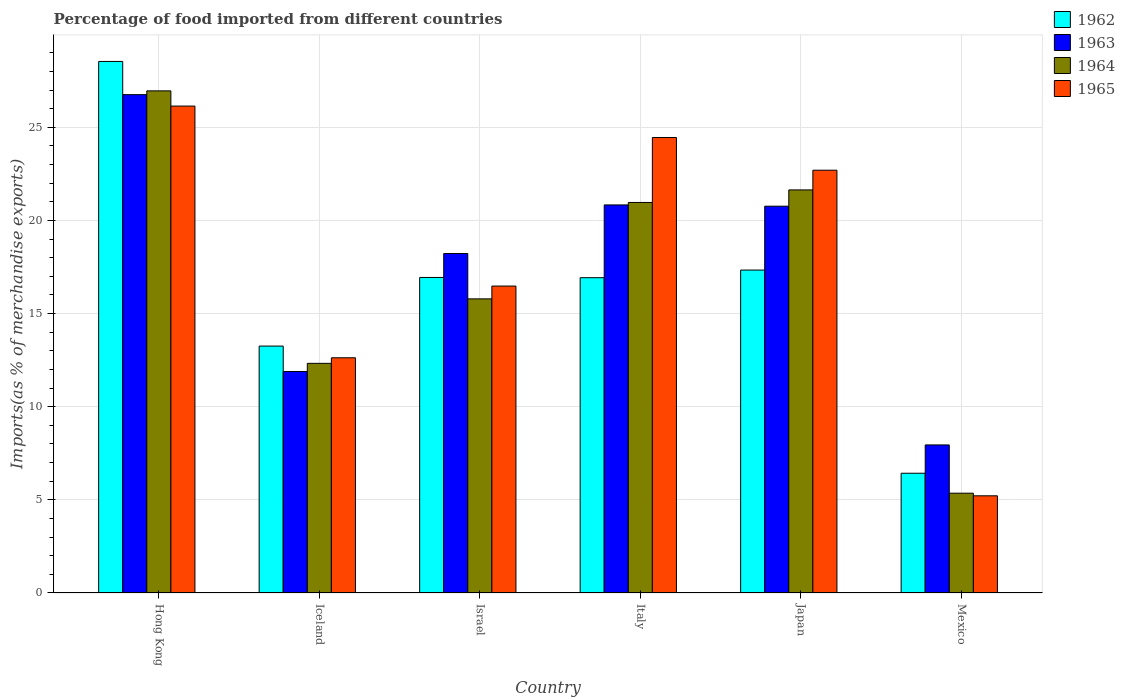Are the number of bars per tick equal to the number of legend labels?
Keep it short and to the point. Yes. Are the number of bars on each tick of the X-axis equal?
Your answer should be very brief. Yes. How many bars are there on the 1st tick from the left?
Ensure brevity in your answer.  4. How many bars are there on the 4th tick from the right?
Your answer should be compact. 4. What is the label of the 2nd group of bars from the left?
Make the answer very short. Iceland. What is the percentage of imports to different countries in 1963 in Italy?
Make the answer very short. 20.83. Across all countries, what is the maximum percentage of imports to different countries in 1963?
Make the answer very short. 26.75. Across all countries, what is the minimum percentage of imports to different countries in 1962?
Make the answer very short. 6.43. In which country was the percentage of imports to different countries in 1963 maximum?
Provide a succinct answer. Hong Kong. What is the total percentage of imports to different countries in 1963 in the graph?
Offer a terse response. 106.41. What is the difference between the percentage of imports to different countries in 1964 in Hong Kong and that in Israel?
Make the answer very short. 11.17. What is the difference between the percentage of imports to different countries in 1964 in Mexico and the percentage of imports to different countries in 1962 in Hong Kong?
Give a very brief answer. -23.18. What is the average percentage of imports to different countries in 1965 per country?
Provide a short and direct response. 17.94. What is the difference between the percentage of imports to different countries of/in 1962 and percentage of imports to different countries of/in 1965 in Mexico?
Provide a short and direct response. 1.21. In how many countries, is the percentage of imports to different countries in 1963 greater than 3 %?
Make the answer very short. 6. What is the ratio of the percentage of imports to different countries in 1962 in Hong Kong to that in Israel?
Your answer should be compact. 1.68. Is the percentage of imports to different countries in 1965 in Israel less than that in Mexico?
Keep it short and to the point. No. What is the difference between the highest and the second highest percentage of imports to different countries in 1964?
Your answer should be compact. 5.99. What is the difference between the highest and the lowest percentage of imports to different countries in 1965?
Provide a short and direct response. 20.92. What does the 4th bar from the left in Mexico represents?
Your response must be concise. 1965. What does the 1st bar from the right in Mexico represents?
Provide a succinct answer. 1965. Is it the case that in every country, the sum of the percentage of imports to different countries in 1963 and percentage of imports to different countries in 1962 is greater than the percentage of imports to different countries in 1965?
Offer a very short reply. Yes. Are all the bars in the graph horizontal?
Ensure brevity in your answer.  No. How many countries are there in the graph?
Provide a succinct answer. 6. Does the graph contain any zero values?
Provide a short and direct response. No. Where does the legend appear in the graph?
Your answer should be compact. Top right. How are the legend labels stacked?
Your response must be concise. Vertical. What is the title of the graph?
Your response must be concise. Percentage of food imported from different countries. What is the label or title of the Y-axis?
Your answer should be compact. Imports(as % of merchandise exports). What is the Imports(as % of merchandise exports) in 1962 in Hong Kong?
Your response must be concise. 28.53. What is the Imports(as % of merchandise exports) in 1963 in Hong Kong?
Give a very brief answer. 26.75. What is the Imports(as % of merchandise exports) in 1964 in Hong Kong?
Your answer should be very brief. 26.96. What is the Imports(as % of merchandise exports) of 1965 in Hong Kong?
Offer a terse response. 26.14. What is the Imports(as % of merchandise exports) in 1962 in Iceland?
Offer a terse response. 13.26. What is the Imports(as % of merchandise exports) of 1963 in Iceland?
Your answer should be compact. 11.89. What is the Imports(as % of merchandise exports) in 1964 in Iceland?
Keep it short and to the point. 12.33. What is the Imports(as % of merchandise exports) of 1965 in Iceland?
Keep it short and to the point. 12.63. What is the Imports(as % of merchandise exports) in 1962 in Israel?
Your response must be concise. 16.94. What is the Imports(as % of merchandise exports) of 1963 in Israel?
Offer a very short reply. 18.22. What is the Imports(as % of merchandise exports) in 1964 in Israel?
Make the answer very short. 15.79. What is the Imports(as % of merchandise exports) in 1965 in Israel?
Keep it short and to the point. 16.48. What is the Imports(as % of merchandise exports) of 1962 in Italy?
Ensure brevity in your answer.  16.93. What is the Imports(as % of merchandise exports) of 1963 in Italy?
Give a very brief answer. 20.83. What is the Imports(as % of merchandise exports) in 1964 in Italy?
Offer a very short reply. 20.97. What is the Imports(as % of merchandise exports) of 1965 in Italy?
Offer a terse response. 24.45. What is the Imports(as % of merchandise exports) of 1962 in Japan?
Your response must be concise. 17.34. What is the Imports(as % of merchandise exports) in 1963 in Japan?
Offer a very short reply. 20.76. What is the Imports(as % of merchandise exports) of 1964 in Japan?
Offer a terse response. 21.64. What is the Imports(as % of merchandise exports) of 1965 in Japan?
Provide a succinct answer. 22.7. What is the Imports(as % of merchandise exports) of 1962 in Mexico?
Your answer should be compact. 6.43. What is the Imports(as % of merchandise exports) in 1963 in Mexico?
Offer a very short reply. 7.95. What is the Imports(as % of merchandise exports) in 1964 in Mexico?
Ensure brevity in your answer.  5.36. What is the Imports(as % of merchandise exports) of 1965 in Mexico?
Keep it short and to the point. 5.22. Across all countries, what is the maximum Imports(as % of merchandise exports) in 1962?
Keep it short and to the point. 28.53. Across all countries, what is the maximum Imports(as % of merchandise exports) of 1963?
Your response must be concise. 26.75. Across all countries, what is the maximum Imports(as % of merchandise exports) of 1964?
Ensure brevity in your answer.  26.96. Across all countries, what is the maximum Imports(as % of merchandise exports) of 1965?
Give a very brief answer. 26.14. Across all countries, what is the minimum Imports(as % of merchandise exports) of 1962?
Your answer should be compact. 6.43. Across all countries, what is the minimum Imports(as % of merchandise exports) of 1963?
Offer a very short reply. 7.95. Across all countries, what is the minimum Imports(as % of merchandise exports) in 1964?
Your response must be concise. 5.36. Across all countries, what is the minimum Imports(as % of merchandise exports) of 1965?
Ensure brevity in your answer.  5.22. What is the total Imports(as % of merchandise exports) in 1962 in the graph?
Provide a succinct answer. 99.42. What is the total Imports(as % of merchandise exports) of 1963 in the graph?
Offer a terse response. 106.41. What is the total Imports(as % of merchandise exports) in 1964 in the graph?
Provide a short and direct response. 103.03. What is the total Imports(as % of merchandise exports) of 1965 in the graph?
Your answer should be compact. 107.61. What is the difference between the Imports(as % of merchandise exports) of 1962 in Hong Kong and that in Iceland?
Your answer should be compact. 15.28. What is the difference between the Imports(as % of merchandise exports) of 1963 in Hong Kong and that in Iceland?
Provide a succinct answer. 14.86. What is the difference between the Imports(as % of merchandise exports) of 1964 in Hong Kong and that in Iceland?
Provide a succinct answer. 14.63. What is the difference between the Imports(as % of merchandise exports) of 1965 in Hong Kong and that in Iceland?
Your answer should be compact. 13.51. What is the difference between the Imports(as % of merchandise exports) of 1962 in Hong Kong and that in Israel?
Offer a terse response. 11.6. What is the difference between the Imports(as % of merchandise exports) in 1963 in Hong Kong and that in Israel?
Ensure brevity in your answer.  8.53. What is the difference between the Imports(as % of merchandise exports) in 1964 in Hong Kong and that in Israel?
Your answer should be very brief. 11.17. What is the difference between the Imports(as % of merchandise exports) in 1965 in Hong Kong and that in Israel?
Give a very brief answer. 9.66. What is the difference between the Imports(as % of merchandise exports) in 1962 in Hong Kong and that in Italy?
Provide a short and direct response. 11.61. What is the difference between the Imports(as % of merchandise exports) in 1963 in Hong Kong and that in Italy?
Give a very brief answer. 5.92. What is the difference between the Imports(as % of merchandise exports) of 1964 in Hong Kong and that in Italy?
Provide a short and direct response. 5.99. What is the difference between the Imports(as % of merchandise exports) in 1965 in Hong Kong and that in Italy?
Provide a succinct answer. 1.69. What is the difference between the Imports(as % of merchandise exports) in 1962 in Hong Kong and that in Japan?
Provide a succinct answer. 11.2. What is the difference between the Imports(as % of merchandise exports) in 1963 in Hong Kong and that in Japan?
Offer a very short reply. 5.99. What is the difference between the Imports(as % of merchandise exports) of 1964 in Hong Kong and that in Japan?
Offer a terse response. 5.32. What is the difference between the Imports(as % of merchandise exports) of 1965 in Hong Kong and that in Japan?
Your answer should be compact. 3.44. What is the difference between the Imports(as % of merchandise exports) of 1962 in Hong Kong and that in Mexico?
Offer a terse response. 22.11. What is the difference between the Imports(as % of merchandise exports) in 1963 in Hong Kong and that in Mexico?
Your answer should be compact. 18.8. What is the difference between the Imports(as % of merchandise exports) in 1964 in Hong Kong and that in Mexico?
Make the answer very short. 21.6. What is the difference between the Imports(as % of merchandise exports) of 1965 in Hong Kong and that in Mexico?
Your answer should be compact. 20.92. What is the difference between the Imports(as % of merchandise exports) in 1962 in Iceland and that in Israel?
Offer a very short reply. -3.68. What is the difference between the Imports(as % of merchandise exports) of 1963 in Iceland and that in Israel?
Offer a terse response. -6.33. What is the difference between the Imports(as % of merchandise exports) of 1964 in Iceland and that in Israel?
Provide a succinct answer. -3.46. What is the difference between the Imports(as % of merchandise exports) in 1965 in Iceland and that in Israel?
Your response must be concise. -3.85. What is the difference between the Imports(as % of merchandise exports) in 1962 in Iceland and that in Italy?
Your answer should be compact. -3.67. What is the difference between the Imports(as % of merchandise exports) of 1963 in Iceland and that in Italy?
Your response must be concise. -8.94. What is the difference between the Imports(as % of merchandise exports) of 1964 in Iceland and that in Italy?
Offer a terse response. -8.64. What is the difference between the Imports(as % of merchandise exports) in 1965 in Iceland and that in Italy?
Your answer should be very brief. -11.82. What is the difference between the Imports(as % of merchandise exports) of 1962 in Iceland and that in Japan?
Offer a very short reply. -4.08. What is the difference between the Imports(as % of merchandise exports) in 1963 in Iceland and that in Japan?
Provide a succinct answer. -8.87. What is the difference between the Imports(as % of merchandise exports) of 1964 in Iceland and that in Japan?
Offer a very short reply. -9.31. What is the difference between the Imports(as % of merchandise exports) of 1965 in Iceland and that in Japan?
Make the answer very short. -10.07. What is the difference between the Imports(as % of merchandise exports) of 1962 in Iceland and that in Mexico?
Give a very brief answer. 6.83. What is the difference between the Imports(as % of merchandise exports) in 1963 in Iceland and that in Mexico?
Give a very brief answer. 3.94. What is the difference between the Imports(as % of merchandise exports) in 1964 in Iceland and that in Mexico?
Provide a short and direct response. 6.97. What is the difference between the Imports(as % of merchandise exports) of 1965 in Iceland and that in Mexico?
Provide a short and direct response. 7.41. What is the difference between the Imports(as % of merchandise exports) of 1962 in Israel and that in Italy?
Your answer should be compact. 0.01. What is the difference between the Imports(as % of merchandise exports) in 1963 in Israel and that in Italy?
Give a very brief answer. -2.61. What is the difference between the Imports(as % of merchandise exports) in 1964 in Israel and that in Italy?
Ensure brevity in your answer.  -5.18. What is the difference between the Imports(as % of merchandise exports) of 1965 in Israel and that in Italy?
Your response must be concise. -7.97. What is the difference between the Imports(as % of merchandise exports) in 1962 in Israel and that in Japan?
Offer a terse response. -0.4. What is the difference between the Imports(as % of merchandise exports) in 1963 in Israel and that in Japan?
Your answer should be very brief. -2.54. What is the difference between the Imports(as % of merchandise exports) in 1964 in Israel and that in Japan?
Offer a terse response. -5.85. What is the difference between the Imports(as % of merchandise exports) in 1965 in Israel and that in Japan?
Keep it short and to the point. -6.22. What is the difference between the Imports(as % of merchandise exports) in 1962 in Israel and that in Mexico?
Ensure brevity in your answer.  10.51. What is the difference between the Imports(as % of merchandise exports) of 1963 in Israel and that in Mexico?
Offer a very short reply. 10.28. What is the difference between the Imports(as % of merchandise exports) in 1964 in Israel and that in Mexico?
Provide a short and direct response. 10.43. What is the difference between the Imports(as % of merchandise exports) in 1965 in Israel and that in Mexico?
Offer a terse response. 11.26. What is the difference between the Imports(as % of merchandise exports) in 1962 in Italy and that in Japan?
Make the answer very short. -0.41. What is the difference between the Imports(as % of merchandise exports) of 1963 in Italy and that in Japan?
Ensure brevity in your answer.  0.07. What is the difference between the Imports(as % of merchandise exports) in 1964 in Italy and that in Japan?
Keep it short and to the point. -0.67. What is the difference between the Imports(as % of merchandise exports) in 1965 in Italy and that in Japan?
Keep it short and to the point. 1.76. What is the difference between the Imports(as % of merchandise exports) of 1962 in Italy and that in Mexico?
Make the answer very short. 10.5. What is the difference between the Imports(as % of merchandise exports) in 1963 in Italy and that in Mexico?
Provide a succinct answer. 12.88. What is the difference between the Imports(as % of merchandise exports) of 1964 in Italy and that in Mexico?
Your response must be concise. 15.61. What is the difference between the Imports(as % of merchandise exports) of 1965 in Italy and that in Mexico?
Offer a terse response. 19.24. What is the difference between the Imports(as % of merchandise exports) in 1962 in Japan and that in Mexico?
Ensure brevity in your answer.  10.91. What is the difference between the Imports(as % of merchandise exports) of 1963 in Japan and that in Mexico?
Offer a very short reply. 12.82. What is the difference between the Imports(as % of merchandise exports) of 1964 in Japan and that in Mexico?
Your answer should be compact. 16.28. What is the difference between the Imports(as % of merchandise exports) of 1965 in Japan and that in Mexico?
Your answer should be very brief. 17.48. What is the difference between the Imports(as % of merchandise exports) of 1962 in Hong Kong and the Imports(as % of merchandise exports) of 1963 in Iceland?
Give a very brief answer. 16.65. What is the difference between the Imports(as % of merchandise exports) of 1962 in Hong Kong and the Imports(as % of merchandise exports) of 1964 in Iceland?
Ensure brevity in your answer.  16.21. What is the difference between the Imports(as % of merchandise exports) of 1962 in Hong Kong and the Imports(as % of merchandise exports) of 1965 in Iceland?
Your answer should be very brief. 15.91. What is the difference between the Imports(as % of merchandise exports) of 1963 in Hong Kong and the Imports(as % of merchandise exports) of 1964 in Iceland?
Offer a very short reply. 14.43. What is the difference between the Imports(as % of merchandise exports) of 1963 in Hong Kong and the Imports(as % of merchandise exports) of 1965 in Iceland?
Provide a succinct answer. 14.13. What is the difference between the Imports(as % of merchandise exports) in 1964 in Hong Kong and the Imports(as % of merchandise exports) in 1965 in Iceland?
Keep it short and to the point. 14.33. What is the difference between the Imports(as % of merchandise exports) in 1962 in Hong Kong and the Imports(as % of merchandise exports) in 1963 in Israel?
Keep it short and to the point. 10.31. What is the difference between the Imports(as % of merchandise exports) in 1962 in Hong Kong and the Imports(as % of merchandise exports) in 1964 in Israel?
Your answer should be very brief. 12.75. What is the difference between the Imports(as % of merchandise exports) in 1962 in Hong Kong and the Imports(as % of merchandise exports) in 1965 in Israel?
Provide a succinct answer. 12.06. What is the difference between the Imports(as % of merchandise exports) of 1963 in Hong Kong and the Imports(as % of merchandise exports) of 1964 in Israel?
Your response must be concise. 10.96. What is the difference between the Imports(as % of merchandise exports) in 1963 in Hong Kong and the Imports(as % of merchandise exports) in 1965 in Israel?
Your answer should be compact. 10.28. What is the difference between the Imports(as % of merchandise exports) in 1964 in Hong Kong and the Imports(as % of merchandise exports) in 1965 in Israel?
Offer a terse response. 10.48. What is the difference between the Imports(as % of merchandise exports) in 1962 in Hong Kong and the Imports(as % of merchandise exports) in 1963 in Italy?
Provide a succinct answer. 7.7. What is the difference between the Imports(as % of merchandise exports) in 1962 in Hong Kong and the Imports(as % of merchandise exports) in 1964 in Italy?
Your answer should be compact. 7.57. What is the difference between the Imports(as % of merchandise exports) in 1962 in Hong Kong and the Imports(as % of merchandise exports) in 1965 in Italy?
Provide a succinct answer. 4.08. What is the difference between the Imports(as % of merchandise exports) of 1963 in Hong Kong and the Imports(as % of merchandise exports) of 1964 in Italy?
Ensure brevity in your answer.  5.79. What is the difference between the Imports(as % of merchandise exports) in 1963 in Hong Kong and the Imports(as % of merchandise exports) in 1965 in Italy?
Ensure brevity in your answer.  2.3. What is the difference between the Imports(as % of merchandise exports) in 1964 in Hong Kong and the Imports(as % of merchandise exports) in 1965 in Italy?
Give a very brief answer. 2.5. What is the difference between the Imports(as % of merchandise exports) of 1962 in Hong Kong and the Imports(as % of merchandise exports) of 1963 in Japan?
Your answer should be compact. 7.77. What is the difference between the Imports(as % of merchandise exports) of 1962 in Hong Kong and the Imports(as % of merchandise exports) of 1964 in Japan?
Your response must be concise. 6.9. What is the difference between the Imports(as % of merchandise exports) in 1962 in Hong Kong and the Imports(as % of merchandise exports) in 1965 in Japan?
Keep it short and to the point. 5.84. What is the difference between the Imports(as % of merchandise exports) of 1963 in Hong Kong and the Imports(as % of merchandise exports) of 1964 in Japan?
Offer a terse response. 5.11. What is the difference between the Imports(as % of merchandise exports) in 1963 in Hong Kong and the Imports(as % of merchandise exports) in 1965 in Japan?
Offer a very short reply. 4.06. What is the difference between the Imports(as % of merchandise exports) of 1964 in Hong Kong and the Imports(as % of merchandise exports) of 1965 in Japan?
Offer a terse response. 4.26. What is the difference between the Imports(as % of merchandise exports) of 1962 in Hong Kong and the Imports(as % of merchandise exports) of 1963 in Mexico?
Your answer should be very brief. 20.59. What is the difference between the Imports(as % of merchandise exports) of 1962 in Hong Kong and the Imports(as % of merchandise exports) of 1964 in Mexico?
Provide a short and direct response. 23.18. What is the difference between the Imports(as % of merchandise exports) in 1962 in Hong Kong and the Imports(as % of merchandise exports) in 1965 in Mexico?
Keep it short and to the point. 23.32. What is the difference between the Imports(as % of merchandise exports) of 1963 in Hong Kong and the Imports(as % of merchandise exports) of 1964 in Mexico?
Make the answer very short. 21.4. What is the difference between the Imports(as % of merchandise exports) in 1963 in Hong Kong and the Imports(as % of merchandise exports) in 1965 in Mexico?
Your response must be concise. 21.54. What is the difference between the Imports(as % of merchandise exports) of 1964 in Hong Kong and the Imports(as % of merchandise exports) of 1965 in Mexico?
Offer a terse response. 21.74. What is the difference between the Imports(as % of merchandise exports) of 1962 in Iceland and the Imports(as % of merchandise exports) of 1963 in Israel?
Offer a terse response. -4.97. What is the difference between the Imports(as % of merchandise exports) in 1962 in Iceland and the Imports(as % of merchandise exports) in 1964 in Israel?
Provide a succinct answer. -2.53. What is the difference between the Imports(as % of merchandise exports) of 1962 in Iceland and the Imports(as % of merchandise exports) of 1965 in Israel?
Provide a short and direct response. -3.22. What is the difference between the Imports(as % of merchandise exports) of 1963 in Iceland and the Imports(as % of merchandise exports) of 1964 in Israel?
Your answer should be compact. -3.9. What is the difference between the Imports(as % of merchandise exports) of 1963 in Iceland and the Imports(as % of merchandise exports) of 1965 in Israel?
Make the answer very short. -4.59. What is the difference between the Imports(as % of merchandise exports) of 1964 in Iceland and the Imports(as % of merchandise exports) of 1965 in Israel?
Give a very brief answer. -4.15. What is the difference between the Imports(as % of merchandise exports) of 1962 in Iceland and the Imports(as % of merchandise exports) of 1963 in Italy?
Give a very brief answer. -7.58. What is the difference between the Imports(as % of merchandise exports) in 1962 in Iceland and the Imports(as % of merchandise exports) in 1964 in Italy?
Give a very brief answer. -7.71. What is the difference between the Imports(as % of merchandise exports) in 1962 in Iceland and the Imports(as % of merchandise exports) in 1965 in Italy?
Give a very brief answer. -11.2. What is the difference between the Imports(as % of merchandise exports) of 1963 in Iceland and the Imports(as % of merchandise exports) of 1964 in Italy?
Your answer should be compact. -9.08. What is the difference between the Imports(as % of merchandise exports) of 1963 in Iceland and the Imports(as % of merchandise exports) of 1965 in Italy?
Provide a short and direct response. -12.56. What is the difference between the Imports(as % of merchandise exports) of 1964 in Iceland and the Imports(as % of merchandise exports) of 1965 in Italy?
Ensure brevity in your answer.  -12.13. What is the difference between the Imports(as % of merchandise exports) of 1962 in Iceland and the Imports(as % of merchandise exports) of 1963 in Japan?
Provide a succinct answer. -7.51. What is the difference between the Imports(as % of merchandise exports) in 1962 in Iceland and the Imports(as % of merchandise exports) in 1964 in Japan?
Make the answer very short. -8.38. What is the difference between the Imports(as % of merchandise exports) of 1962 in Iceland and the Imports(as % of merchandise exports) of 1965 in Japan?
Your answer should be very brief. -9.44. What is the difference between the Imports(as % of merchandise exports) of 1963 in Iceland and the Imports(as % of merchandise exports) of 1964 in Japan?
Keep it short and to the point. -9.75. What is the difference between the Imports(as % of merchandise exports) in 1963 in Iceland and the Imports(as % of merchandise exports) in 1965 in Japan?
Make the answer very short. -10.81. What is the difference between the Imports(as % of merchandise exports) of 1964 in Iceland and the Imports(as % of merchandise exports) of 1965 in Japan?
Offer a terse response. -10.37. What is the difference between the Imports(as % of merchandise exports) of 1962 in Iceland and the Imports(as % of merchandise exports) of 1963 in Mexico?
Provide a short and direct response. 5.31. What is the difference between the Imports(as % of merchandise exports) of 1962 in Iceland and the Imports(as % of merchandise exports) of 1964 in Mexico?
Make the answer very short. 7.9. What is the difference between the Imports(as % of merchandise exports) in 1962 in Iceland and the Imports(as % of merchandise exports) in 1965 in Mexico?
Make the answer very short. 8.04. What is the difference between the Imports(as % of merchandise exports) in 1963 in Iceland and the Imports(as % of merchandise exports) in 1964 in Mexico?
Provide a short and direct response. 6.53. What is the difference between the Imports(as % of merchandise exports) in 1963 in Iceland and the Imports(as % of merchandise exports) in 1965 in Mexico?
Make the answer very short. 6.67. What is the difference between the Imports(as % of merchandise exports) of 1964 in Iceland and the Imports(as % of merchandise exports) of 1965 in Mexico?
Offer a terse response. 7.11. What is the difference between the Imports(as % of merchandise exports) of 1962 in Israel and the Imports(as % of merchandise exports) of 1963 in Italy?
Offer a very short reply. -3.89. What is the difference between the Imports(as % of merchandise exports) in 1962 in Israel and the Imports(as % of merchandise exports) in 1964 in Italy?
Offer a terse response. -4.03. What is the difference between the Imports(as % of merchandise exports) in 1962 in Israel and the Imports(as % of merchandise exports) in 1965 in Italy?
Make the answer very short. -7.51. What is the difference between the Imports(as % of merchandise exports) in 1963 in Israel and the Imports(as % of merchandise exports) in 1964 in Italy?
Ensure brevity in your answer.  -2.74. What is the difference between the Imports(as % of merchandise exports) of 1963 in Israel and the Imports(as % of merchandise exports) of 1965 in Italy?
Give a very brief answer. -6.23. What is the difference between the Imports(as % of merchandise exports) in 1964 in Israel and the Imports(as % of merchandise exports) in 1965 in Italy?
Your answer should be compact. -8.66. What is the difference between the Imports(as % of merchandise exports) in 1962 in Israel and the Imports(as % of merchandise exports) in 1963 in Japan?
Give a very brief answer. -3.83. What is the difference between the Imports(as % of merchandise exports) of 1962 in Israel and the Imports(as % of merchandise exports) of 1964 in Japan?
Provide a short and direct response. -4.7. What is the difference between the Imports(as % of merchandise exports) in 1962 in Israel and the Imports(as % of merchandise exports) in 1965 in Japan?
Make the answer very short. -5.76. What is the difference between the Imports(as % of merchandise exports) of 1963 in Israel and the Imports(as % of merchandise exports) of 1964 in Japan?
Make the answer very short. -3.41. What is the difference between the Imports(as % of merchandise exports) in 1963 in Israel and the Imports(as % of merchandise exports) in 1965 in Japan?
Offer a very short reply. -4.47. What is the difference between the Imports(as % of merchandise exports) of 1964 in Israel and the Imports(as % of merchandise exports) of 1965 in Japan?
Provide a short and direct response. -6.91. What is the difference between the Imports(as % of merchandise exports) of 1962 in Israel and the Imports(as % of merchandise exports) of 1963 in Mexico?
Provide a short and direct response. 8.99. What is the difference between the Imports(as % of merchandise exports) in 1962 in Israel and the Imports(as % of merchandise exports) in 1964 in Mexico?
Your response must be concise. 11.58. What is the difference between the Imports(as % of merchandise exports) of 1962 in Israel and the Imports(as % of merchandise exports) of 1965 in Mexico?
Make the answer very short. 11.72. What is the difference between the Imports(as % of merchandise exports) of 1963 in Israel and the Imports(as % of merchandise exports) of 1964 in Mexico?
Your response must be concise. 12.87. What is the difference between the Imports(as % of merchandise exports) of 1963 in Israel and the Imports(as % of merchandise exports) of 1965 in Mexico?
Offer a very short reply. 13.01. What is the difference between the Imports(as % of merchandise exports) in 1964 in Israel and the Imports(as % of merchandise exports) in 1965 in Mexico?
Your answer should be very brief. 10.57. What is the difference between the Imports(as % of merchandise exports) in 1962 in Italy and the Imports(as % of merchandise exports) in 1963 in Japan?
Your response must be concise. -3.84. What is the difference between the Imports(as % of merchandise exports) in 1962 in Italy and the Imports(as % of merchandise exports) in 1964 in Japan?
Ensure brevity in your answer.  -4.71. What is the difference between the Imports(as % of merchandise exports) of 1962 in Italy and the Imports(as % of merchandise exports) of 1965 in Japan?
Provide a short and direct response. -5.77. What is the difference between the Imports(as % of merchandise exports) of 1963 in Italy and the Imports(as % of merchandise exports) of 1964 in Japan?
Keep it short and to the point. -0.81. What is the difference between the Imports(as % of merchandise exports) in 1963 in Italy and the Imports(as % of merchandise exports) in 1965 in Japan?
Offer a terse response. -1.86. What is the difference between the Imports(as % of merchandise exports) of 1964 in Italy and the Imports(as % of merchandise exports) of 1965 in Japan?
Provide a short and direct response. -1.73. What is the difference between the Imports(as % of merchandise exports) of 1962 in Italy and the Imports(as % of merchandise exports) of 1963 in Mexico?
Ensure brevity in your answer.  8.98. What is the difference between the Imports(as % of merchandise exports) in 1962 in Italy and the Imports(as % of merchandise exports) in 1964 in Mexico?
Your response must be concise. 11.57. What is the difference between the Imports(as % of merchandise exports) in 1962 in Italy and the Imports(as % of merchandise exports) in 1965 in Mexico?
Offer a terse response. 11.71. What is the difference between the Imports(as % of merchandise exports) of 1963 in Italy and the Imports(as % of merchandise exports) of 1964 in Mexico?
Make the answer very short. 15.48. What is the difference between the Imports(as % of merchandise exports) in 1963 in Italy and the Imports(as % of merchandise exports) in 1965 in Mexico?
Keep it short and to the point. 15.62. What is the difference between the Imports(as % of merchandise exports) of 1964 in Italy and the Imports(as % of merchandise exports) of 1965 in Mexico?
Offer a very short reply. 15.75. What is the difference between the Imports(as % of merchandise exports) in 1962 in Japan and the Imports(as % of merchandise exports) in 1963 in Mexico?
Offer a terse response. 9.39. What is the difference between the Imports(as % of merchandise exports) in 1962 in Japan and the Imports(as % of merchandise exports) in 1964 in Mexico?
Offer a very short reply. 11.98. What is the difference between the Imports(as % of merchandise exports) in 1962 in Japan and the Imports(as % of merchandise exports) in 1965 in Mexico?
Offer a terse response. 12.12. What is the difference between the Imports(as % of merchandise exports) in 1963 in Japan and the Imports(as % of merchandise exports) in 1964 in Mexico?
Provide a short and direct response. 15.41. What is the difference between the Imports(as % of merchandise exports) of 1963 in Japan and the Imports(as % of merchandise exports) of 1965 in Mexico?
Make the answer very short. 15.55. What is the difference between the Imports(as % of merchandise exports) of 1964 in Japan and the Imports(as % of merchandise exports) of 1965 in Mexico?
Your answer should be very brief. 16.42. What is the average Imports(as % of merchandise exports) in 1962 per country?
Ensure brevity in your answer.  16.57. What is the average Imports(as % of merchandise exports) of 1963 per country?
Provide a succinct answer. 17.74. What is the average Imports(as % of merchandise exports) of 1964 per country?
Give a very brief answer. 17.17. What is the average Imports(as % of merchandise exports) in 1965 per country?
Make the answer very short. 17.94. What is the difference between the Imports(as % of merchandise exports) of 1962 and Imports(as % of merchandise exports) of 1963 in Hong Kong?
Offer a terse response. 1.78. What is the difference between the Imports(as % of merchandise exports) of 1962 and Imports(as % of merchandise exports) of 1964 in Hong Kong?
Keep it short and to the point. 1.58. What is the difference between the Imports(as % of merchandise exports) in 1962 and Imports(as % of merchandise exports) in 1965 in Hong Kong?
Provide a short and direct response. 2.4. What is the difference between the Imports(as % of merchandise exports) of 1963 and Imports(as % of merchandise exports) of 1964 in Hong Kong?
Offer a terse response. -0.2. What is the difference between the Imports(as % of merchandise exports) of 1963 and Imports(as % of merchandise exports) of 1965 in Hong Kong?
Give a very brief answer. 0.61. What is the difference between the Imports(as % of merchandise exports) of 1964 and Imports(as % of merchandise exports) of 1965 in Hong Kong?
Your answer should be compact. 0.82. What is the difference between the Imports(as % of merchandise exports) in 1962 and Imports(as % of merchandise exports) in 1963 in Iceland?
Ensure brevity in your answer.  1.37. What is the difference between the Imports(as % of merchandise exports) of 1962 and Imports(as % of merchandise exports) of 1964 in Iceland?
Provide a succinct answer. 0.93. What is the difference between the Imports(as % of merchandise exports) in 1962 and Imports(as % of merchandise exports) in 1965 in Iceland?
Keep it short and to the point. 0.63. What is the difference between the Imports(as % of merchandise exports) in 1963 and Imports(as % of merchandise exports) in 1964 in Iceland?
Provide a succinct answer. -0.44. What is the difference between the Imports(as % of merchandise exports) in 1963 and Imports(as % of merchandise exports) in 1965 in Iceland?
Make the answer very short. -0.74. What is the difference between the Imports(as % of merchandise exports) of 1964 and Imports(as % of merchandise exports) of 1965 in Iceland?
Give a very brief answer. -0.3. What is the difference between the Imports(as % of merchandise exports) in 1962 and Imports(as % of merchandise exports) in 1963 in Israel?
Provide a succinct answer. -1.29. What is the difference between the Imports(as % of merchandise exports) in 1962 and Imports(as % of merchandise exports) in 1964 in Israel?
Offer a terse response. 1.15. What is the difference between the Imports(as % of merchandise exports) in 1962 and Imports(as % of merchandise exports) in 1965 in Israel?
Make the answer very short. 0.46. What is the difference between the Imports(as % of merchandise exports) of 1963 and Imports(as % of merchandise exports) of 1964 in Israel?
Offer a very short reply. 2.43. What is the difference between the Imports(as % of merchandise exports) of 1963 and Imports(as % of merchandise exports) of 1965 in Israel?
Offer a terse response. 1.75. What is the difference between the Imports(as % of merchandise exports) in 1964 and Imports(as % of merchandise exports) in 1965 in Israel?
Your answer should be very brief. -0.69. What is the difference between the Imports(as % of merchandise exports) of 1962 and Imports(as % of merchandise exports) of 1963 in Italy?
Your answer should be compact. -3.91. What is the difference between the Imports(as % of merchandise exports) in 1962 and Imports(as % of merchandise exports) in 1964 in Italy?
Provide a short and direct response. -4.04. What is the difference between the Imports(as % of merchandise exports) in 1962 and Imports(as % of merchandise exports) in 1965 in Italy?
Ensure brevity in your answer.  -7.53. What is the difference between the Imports(as % of merchandise exports) of 1963 and Imports(as % of merchandise exports) of 1964 in Italy?
Your answer should be compact. -0.13. What is the difference between the Imports(as % of merchandise exports) of 1963 and Imports(as % of merchandise exports) of 1965 in Italy?
Make the answer very short. -3.62. What is the difference between the Imports(as % of merchandise exports) in 1964 and Imports(as % of merchandise exports) in 1965 in Italy?
Your answer should be very brief. -3.49. What is the difference between the Imports(as % of merchandise exports) of 1962 and Imports(as % of merchandise exports) of 1963 in Japan?
Give a very brief answer. -3.43. What is the difference between the Imports(as % of merchandise exports) of 1962 and Imports(as % of merchandise exports) of 1964 in Japan?
Provide a succinct answer. -4.3. What is the difference between the Imports(as % of merchandise exports) of 1962 and Imports(as % of merchandise exports) of 1965 in Japan?
Make the answer very short. -5.36. What is the difference between the Imports(as % of merchandise exports) in 1963 and Imports(as % of merchandise exports) in 1964 in Japan?
Your response must be concise. -0.87. What is the difference between the Imports(as % of merchandise exports) of 1963 and Imports(as % of merchandise exports) of 1965 in Japan?
Your response must be concise. -1.93. What is the difference between the Imports(as % of merchandise exports) of 1964 and Imports(as % of merchandise exports) of 1965 in Japan?
Your response must be concise. -1.06. What is the difference between the Imports(as % of merchandise exports) of 1962 and Imports(as % of merchandise exports) of 1963 in Mexico?
Provide a short and direct response. -1.52. What is the difference between the Imports(as % of merchandise exports) in 1962 and Imports(as % of merchandise exports) in 1964 in Mexico?
Ensure brevity in your answer.  1.07. What is the difference between the Imports(as % of merchandise exports) of 1962 and Imports(as % of merchandise exports) of 1965 in Mexico?
Provide a short and direct response. 1.21. What is the difference between the Imports(as % of merchandise exports) of 1963 and Imports(as % of merchandise exports) of 1964 in Mexico?
Your response must be concise. 2.59. What is the difference between the Imports(as % of merchandise exports) in 1963 and Imports(as % of merchandise exports) in 1965 in Mexico?
Keep it short and to the point. 2.73. What is the difference between the Imports(as % of merchandise exports) in 1964 and Imports(as % of merchandise exports) in 1965 in Mexico?
Your answer should be compact. 0.14. What is the ratio of the Imports(as % of merchandise exports) of 1962 in Hong Kong to that in Iceland?
Your answer should be compact. 2.15. What is the ratio of the Imports(as % of merchandise exports) of 1963 in Hong Kong to that in Iceland?
Your answer should be compact. 2.25. What is the ratio of the Imports(as % of merchandise exports) of 1964 in Hong Kong to that in Iceland?
Provide a succinct answer. 2.19. What is the ratio of the Imports(as % of merchandise exports) in 1965 in Hong Kong to that in Iceland?
Your answer should be compact. 2.07. What is the ratio of the Imports(as % of merchandise exports) of 1962 in Hong Kong to that in Israel?
Provide a succinct answer. 1.68. What is the ratio of the Imports(as % of merchandise exports) in 1963 in Hong Kong to that in Israel?
Offer a very short reply. 1.47. What is the ratio of the Imports(as % of merchandise exports) in 1964 in Hong Kong to that in Israel?
Keep it short and to the point. 1.71. What is the ratio of the Imports(as % of merchandise exports) in 1965 in Hong Kong to that in Israel?
Offer a terse response. 1.59. What is the ratio of the Imports(as % of merchandise exports) of 1962 in Hong Kong to that in Italy?
Your answer should be very brief. 1.69. What is the ratio of the Imports(as % of merchandise exports) of 1963 in Hong Kong to that in Italy?
Offer a very short reply. 1.28. What is the ratio of the Imports(as % of merchandise exports) in 1965 in Hong Kong to that in Italy?
Your response must be concise. 1.07. What is the ratio of the Imports(as % of merchandise exports) in 1962 in Hong Kong to that in Japan?
Your response must be concise. 1.65. What is the ratio of the Imports(as % of merchandise exports) in 1963 in Hong Kong to that in Japan?
Your answer should be very brief. 1.29. What is the ratio of the Imports(as % of merchandise exports) in 1964 in Hong Kong to that in Japan?
Offer a very short reply. 1.25. What is the ratio of the Imports(as % of merchandise exports) in 1965 in Hong Kong to that in Japan?
Keep it short and to the point. 1.15. What is the ratio of the Imports(as % of merchandise exports) of 1962 in Hong Kong to that in Mexico?
Provide a short and direct response. 4.44. What is the ratio of the Imports(as % of merchandise exports) of 1963 in Hong Kong to that in Mexico?
Keep it short and to the point. 3.37. What is the ratio of the Imports(as % of merchandise exports) in 1964 in Hong Kong to that in Mexico?
Offer a very short reply. 5.03. What is the ratio of the Imports(as % of merchandise exports) of 1965 in Hong Kong to that in Mexico?
Keep it short and to the point. 5.01. What is the ratio of the Imports(as % of merchandise exports) in 1962 in Iceland to that in Israel?
Offer a very short reply. 0.78. What is the ratio of the Imports(as % of merchandise exports) in 1963 in Iceland to that in Israel?
Your answer should be very brief. 0.65. What is the ratio of the Imports(as % of merchandise exports) of 1964 in Iceland to that in Israel?
Your answer should be compact. 0.78. What is the ratio of the Imports(as % of merchandise exports) of 1965 in Iceland to that in Israel?
Offer a very short reply. 0.77. What is the ratio of the Imports(as % of merchandise exports) of 1962 in Iceland to that in Italy?
Ensure brevity in your answer.  0.78. What is the ratio of the Imports(as % of merchandise exports) of 1963 in Iceland to that in Italy?
Your answer should be very brief. 0.57. What is the ratio of the Imports(as % of merchandise exports) in 1964 in Iceland to that in Italy?
Offer a terse response. 0.59. What is the ratio of the Imports(as % of merchandise exports) of 1965 in Iceland to that in Italy?
Provide a short and direct response. 0.52. What is the ratio of the Imports(as % of merchandise exports) in 1962 in Iceland to that in Japan?
Give a very brief answer. 0.76. What is the ratio of the Imports(as % of merchandise exports) in 1963 in Iceland to that in Japan?
Ensure brevity in your answer.  0.57. What is the ratio of the Imports(as % of merchandise exports) in 1964 in Iceland to that in Japan?
Provide a succinct answer. 0.57. What is the ratio of the Imports(as % of merchandise exports) of 1965 in Iceland to that in Japan?
Provide a succinct answer. 0.56. What is the ratio of the Imports(as % of merchandise exports) in 1962 in Iceland to that in Mexico?
Keep it short and to the point. 2.06. What is the ratio of the Imports(as % of merchandise exports) of 1963 in Iceland to that in Mexico?
Ensure brevity in your answer.  1.5. What is the ratio of the Imports(as % of merchandise exports) in 1964 in Iceland to that in Mexico?
Offer a very short reply. 2.3. What is the ratio of the Imports(as % of merchandise exports) of 1965 in Iceland to that in Mexico?
Keep it short and to the point. 2.42. What is the ratio of the Imports(as % of merchandise exports) in 1962 in Israel to that in Italy?
Make the answer very short. 1. What is the ratio of the Imports(as % of merchandise exports) of 1963 in Israel to that in Italy?
Ensure brevity in your answer.  0.87. What is the ratio of the Imports(as % of merchandise exports) of 1964 in Israel to that in Italy?
Provide a short and direct response. 0.75. What is the ratio of the Imports(as % of merchandise exports) in 1965 in Israel to that in Italy?
Provide a succinct answer. 0.67. What is the ratio of the Imports(as % of merchandise exports) of 1962 in Israel to that in Japan?
Offer a very short reply. 0.98. What is the ratio of the Imports(as % of merchandise exports) in 1963 in Israel to that in Japan?
Offer a terse response. 0.88. What is the ratio of the Imports(as % of merchandise exports) of 1964 in Israel to that in Japan?
Make the answer very short. 0.73. What is the ratio of the Imports(as % of merchandise exports) in 1965 in Israel to that in Japan?
Your answer should be very brief. 0.73. What is the ratio of the Imports(as % of merchandise exports) of 1962 in Israel to that in Mexico?
Your answer should be compact. 2.63. What is the ratio of the Imports(as % of merchandise exports) of 1963 in Israel to that in Mexico?
Ensure brevity in your answer.  2.29. What is the ratio of the Imports(as % of merchandise exports) of 1964 in Israel to that in Mexico?
Your answer should be compact. 2.95. What is the ratio of the Imports(as % of merchandise exports) in 1965 in Israel to that in Mexico?
Offer a very short reply. 3.16. What is the ratio of the Imports(as % of merchandise exports) in 1962 in Italy to that in Japan?
Make the answer very short. 0.98. What is the ratio of the Imports(as % of merchandise exports) in 1963 in Italy to that in Japan?
Offer a very short reply. 1. What is the ratio of the Imports(as % of merchandise exports) of 1964 in Italy to that in Japan?
Offer a very short reply. 0.97. What is the ratio of the Imports(as % of merchandise exports) of 1965 in Italy to that in Japan?
Ensure brevity in your answer.  1.08. What is the ratio of the Imports(as % of merchandise exports) of 1962 in Italy to that in Mexico?
Offer a very short reply. 2.63. What is the ratio of the Imports(as % of merchandise exports) of 1963 in Italy to that in Mexico?
Ensure brevity in your answer.  2.62. What is the ratio of the Imports(as % of merchandise exports) of 1964 in Italy to that in Mexico?
Provide a succinct answer. 3.91. What is the ratio of the Imports(as % of merchandise exports) in 1965 in Italy to that in Mexico?
Your answer should be compact. 4.69. What is the ratio of the Imports(as % of merchandise exports) of 1962 in Japan to that in Mexico?
Your response must be concise. 2.7. What is the ratio of the Imports(as % of merchandise exports) in 1963 in Japan to that in Mexico?
Your response must be concise. 2.61. What is the ratio of the Imports(as % of merchandise exports) of 1964 in Japan to that in Mexico?
Give a very brief answer. 4.04. What is the ratio of the Imports(as % of merchandise exports) in 1965 in Japan to that in Mexico?
Your answer should be compact. 4.35. What is the difference between the highest and the second highest Imports(as % of merchandise exports) in 1962?
Make the answer very short. 11.2. What is the difference between the highest and the second highest Imports(as % of merchandise exports) of 1963?
Your answer should be very brief. 5.92. What is the difference between the highest and the second highest Imports(as % of merchandise exports) in 1964?
Your answer should be compact. 5.32. What is the difference between the highest and the second highest Imports(as % of merchandise exports) of 1965?
Your answer should be compact. 1.69. What is the difference between the highest and the lowest Imports(as % of merchandise exports) of 1962?
Keep it short and to the point. 22.11. What is the difference between the highest and the lowest Imports(as % of merchandise exports) of 1963?
Your answer should be very brief. 18.8. What is the difference between the highest and the lowest Imports(as % of merchandise exports) in 1964?
Ensure brevity in your answer.  21.6. What is the difference between the highest and the lowest Imports(as % of merchandise exports) of 1965?
Ensure brevity in your answer.  20.92. 